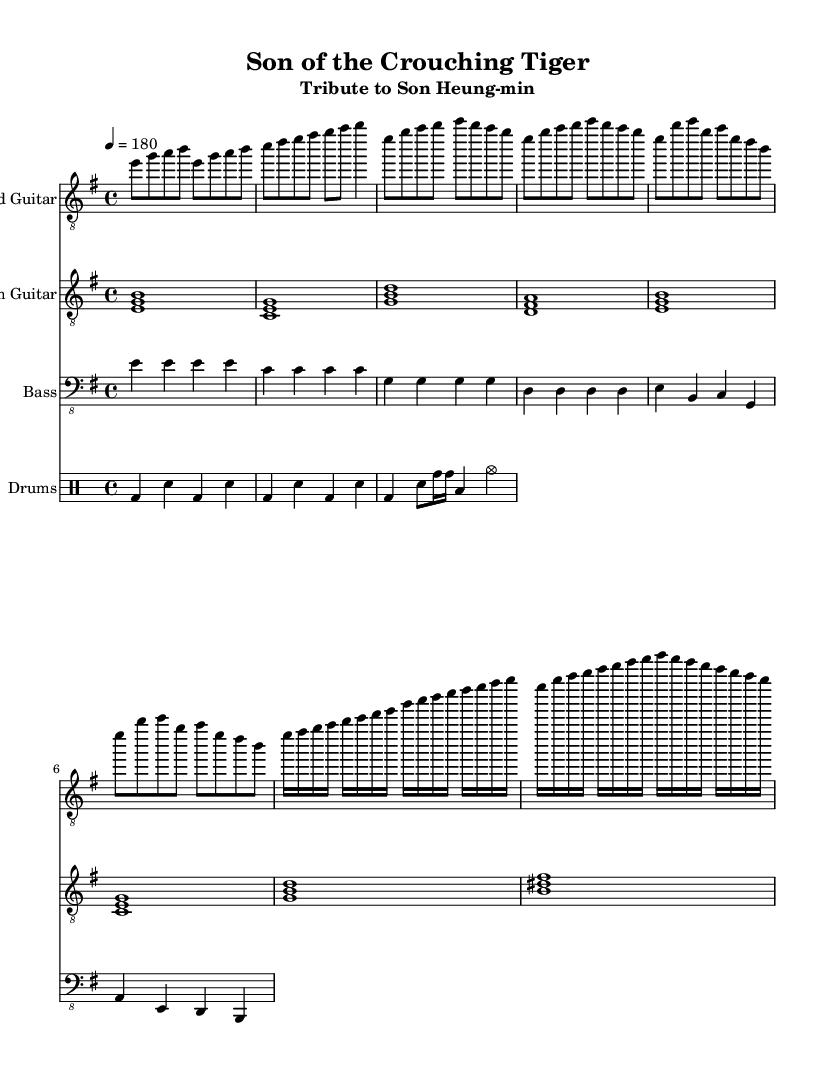What is the key signature of this music? The key signature is E minor, which has one sharp (F#). This can be identified in the music sheet by looking for the sharp symbol indicated at the beginning of the first staff.
Answer: E minor What is the time signature of this piece? The time signature is 4/4, meaning there are four beats per measure and the quarter note gets one beat. This is usually noted at the beginning of the piece, where the time signature is indicated.
Answer: 4/4 What is the tempo marking for this composition? The tempo marking is 4 = 180, which indicates that the quarter note should be played at a speed of 180 beats per minute. This tempo gives the piece a fast-paced character typical of speed metal.
Answer: 180 How many measures are in the intro section? The intro section consists of three measures, which can be counted by observing how many groups of four beats are presented before the music transitions to the verse section.
Answer: 3 What instruments are involved in this arrangement? The instruments in this arrangement are Lead Guitar, Rhythm Guitar, Bass, and Drums. This can be confirmed by looking at the labeled staves at the beginning of the score where each instrument name is indicated.
Answer: Lead Guitar, Rhythm Guitar, Bass, Drums What is the chord for the first measure of the verse? The chord for the first measure of the verse is E minor, which can be identified by noting the notes being played in the rhythm guitar part (e, g, b) and matching them to the chord structure.
Answer: E minor How many beats does the solo section last? The solo section lasts for 8 beats, which can be determined by counting the eighth note values present in that part of the score, where it indicates a continuous progression through notes.
Answer: 8 